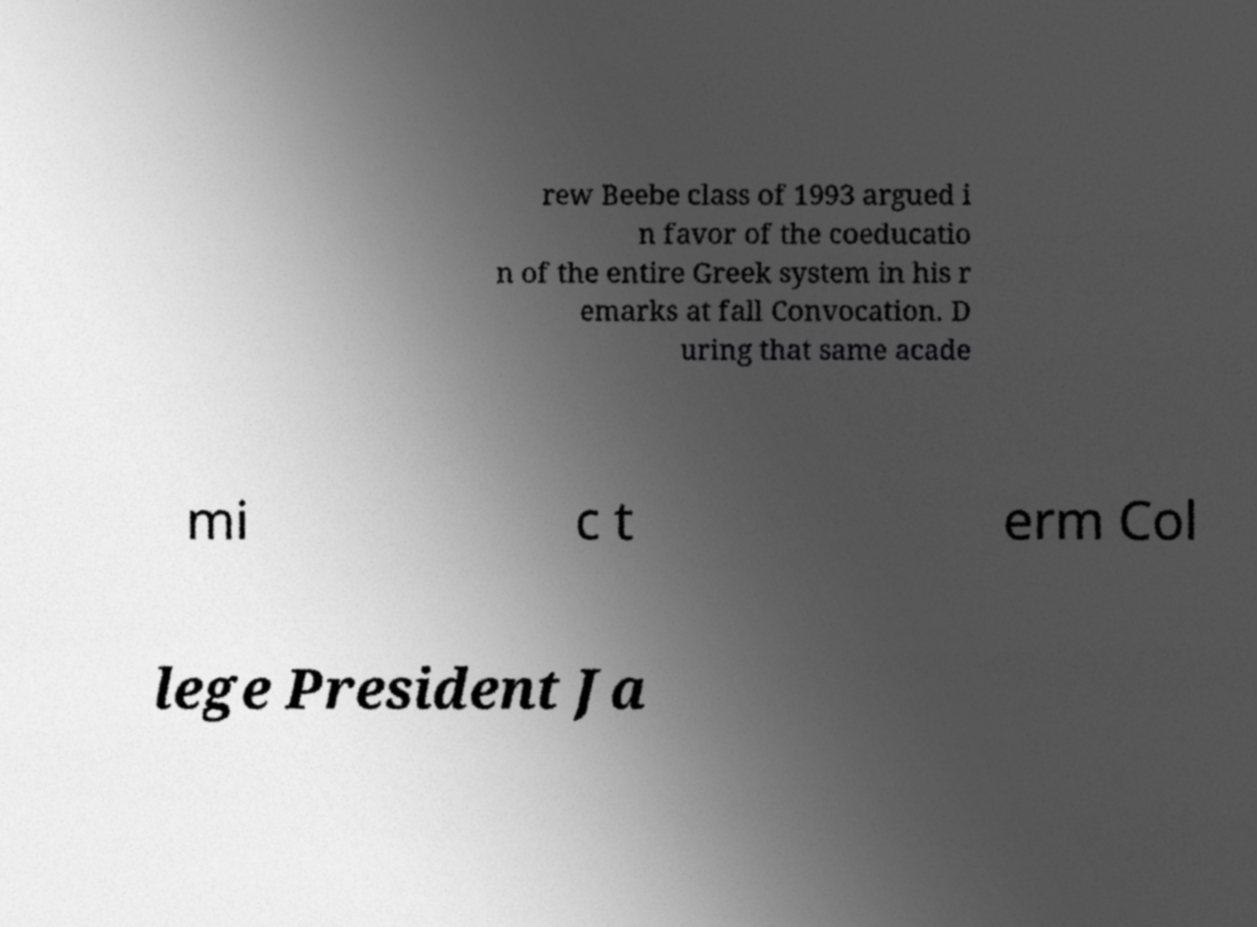What messages or text are displayed in this image? I need them in a readable, typed format. rew Beebe class of 1993 argued i n favor of the coeducatio n of the entire Greek system in his r emarks at fall Convocation. D uring that same acade mi c t erm Col lege President Ja 